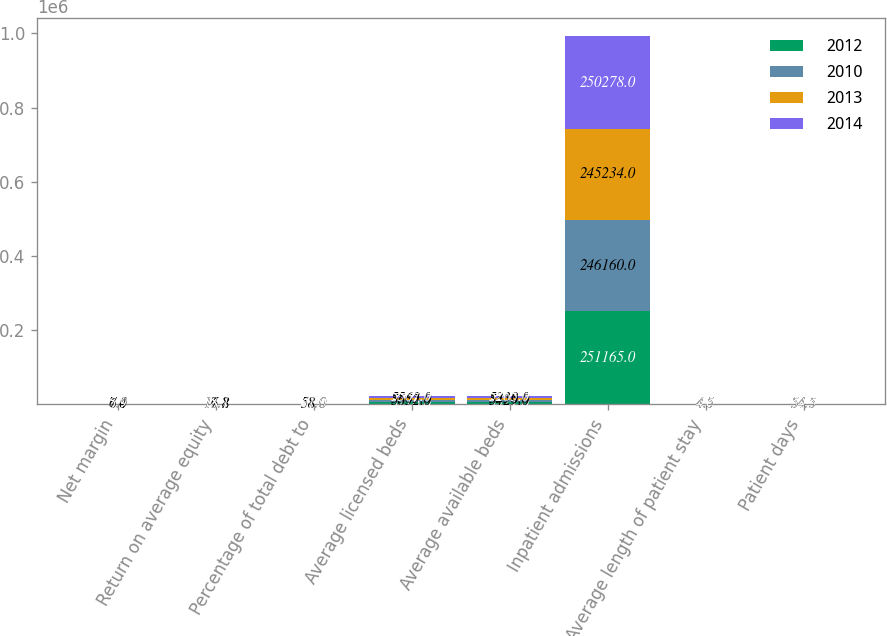<chart> <loc_0><loc_0><loc_500><loc_500><stacked_bar_chart><ecel><fcel>Net margin<fcel>Return on average equity<fcel>Percentage of total debt to<fcel>Average licensed beds<fcel>Average available beds<fcel>Inpatient admissions<fcel>Average length of patient stay<fcel>Patient days<nl><fcel>2012<fcel>6.8<fcel>15.3<fcel>47<fcel>5776<fcel>5571<fcel>251165<fcel>4.6<fcel>54.5<nl><fcel>2010<fcel>7<fcel>16.8<fcel>51<fcel>5652<fcel>5429<fcel>246160<fcel>4.5<fcel>54.5<nl><fcel>2013<fcel>6.4<fcel>17.2<fcel>58<fcel>5563<fcel>5338<fcel>245234<fcel>4.5<fcel>54.5<nl><fcel>2014<fcel>5.9<fcel>18.1<fcel>61<fcel>5567<fcel>5265<fcel>250278<fcel>4.5<fcel>54.5<nl></chart> 